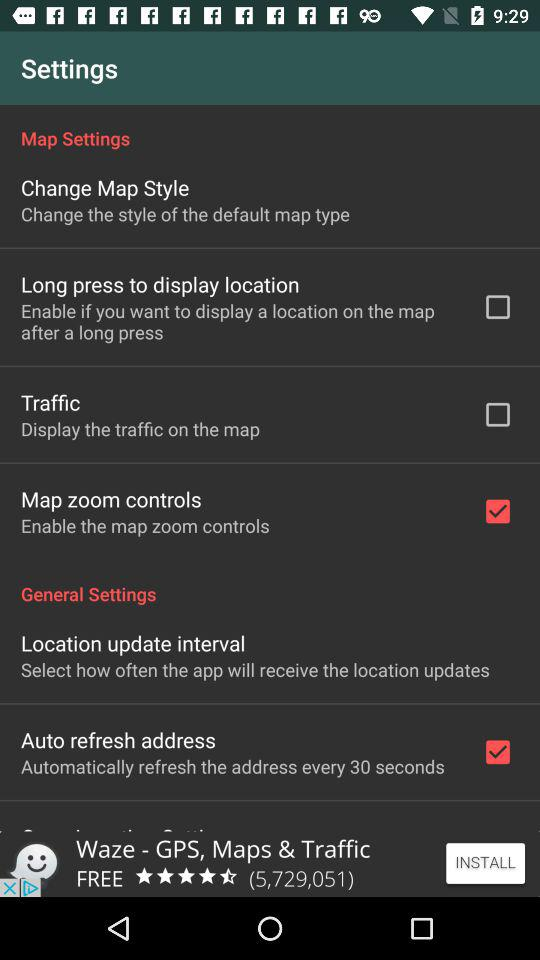How many map settings are there?
Answer the question using a single word or phrase. 4 